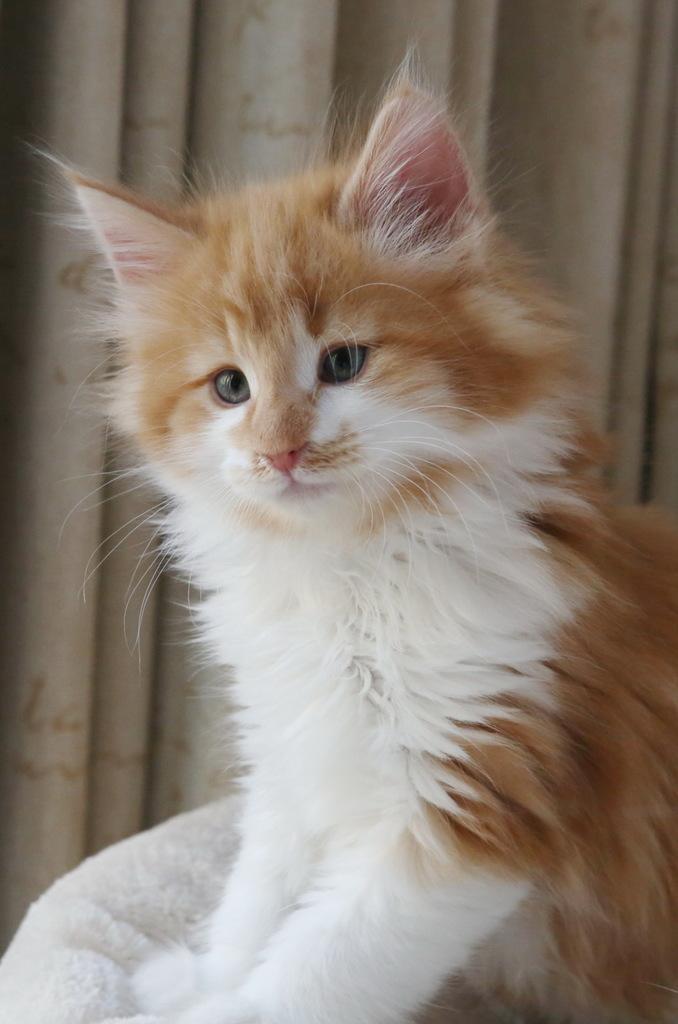Could you give a brief overview of what you see in this image? In the picture I can see cat sitting on a chair, behind there is a curtain. 